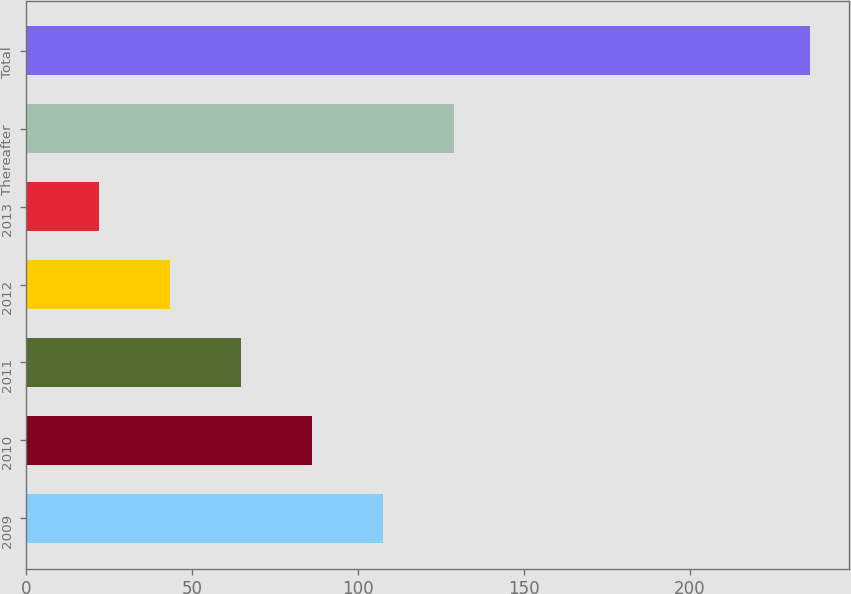Convert chart to OTSL. <chart><loc_0><loc_0><loc_500><loc_500><bar_chart><fcel>2009<fcel>2010<fcel>2011<fcel>2012<fcel>2013<fcel>Thereafter<fcel>Total<nl><fcel>107.6<fcel>86.2<fcel>64.8<fcel>43.4<fcel>22<fcel>129<fcel>236<nl></chart> 